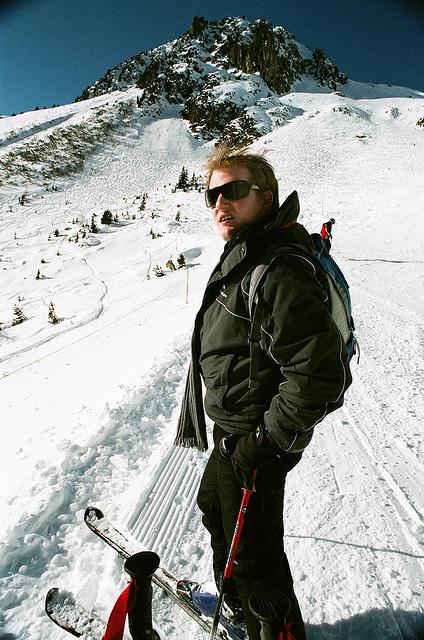Why is it snow on the ground?
Quick response, please. Winter. Does this person have glasses?
Short answer required. Yes. Is the man facing towards the sun?
Concise answer only. Yes. 